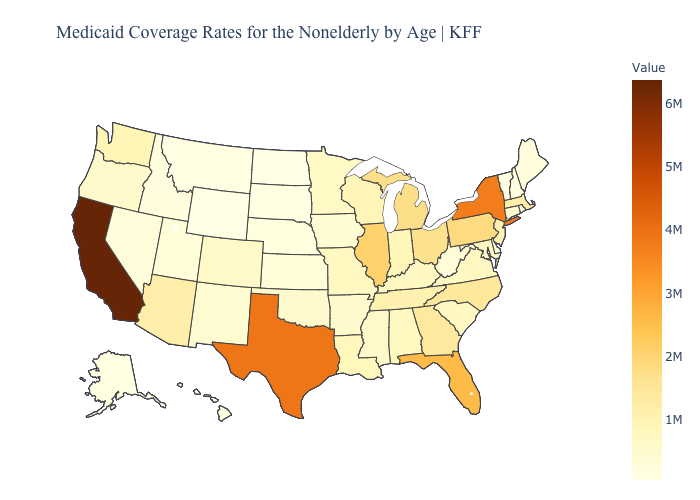Does Delaware have the lowest value in the South?
Be succinct. Yes. Among the states that border Colorado , which have the lowest value?
Be succinct. Wyoming. Does New York have a higher value than South Dakota?
Give a very brief answer. Yes. Does Wyoming have the lowest value in the USA?
Keep it brief. Yes. Which states have the lowest value in the USA?
Be succinct. Wyoming. Does the map have missing data?
Quick response, please. No. 